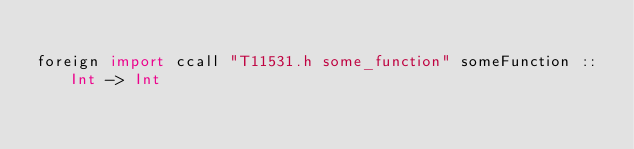<code> <loc_0><loc_0><loc_500><loc_500><_Haskell_>
foreign import ccall "T11531.h some_function" someFunction :: Int -> Int
</code> 